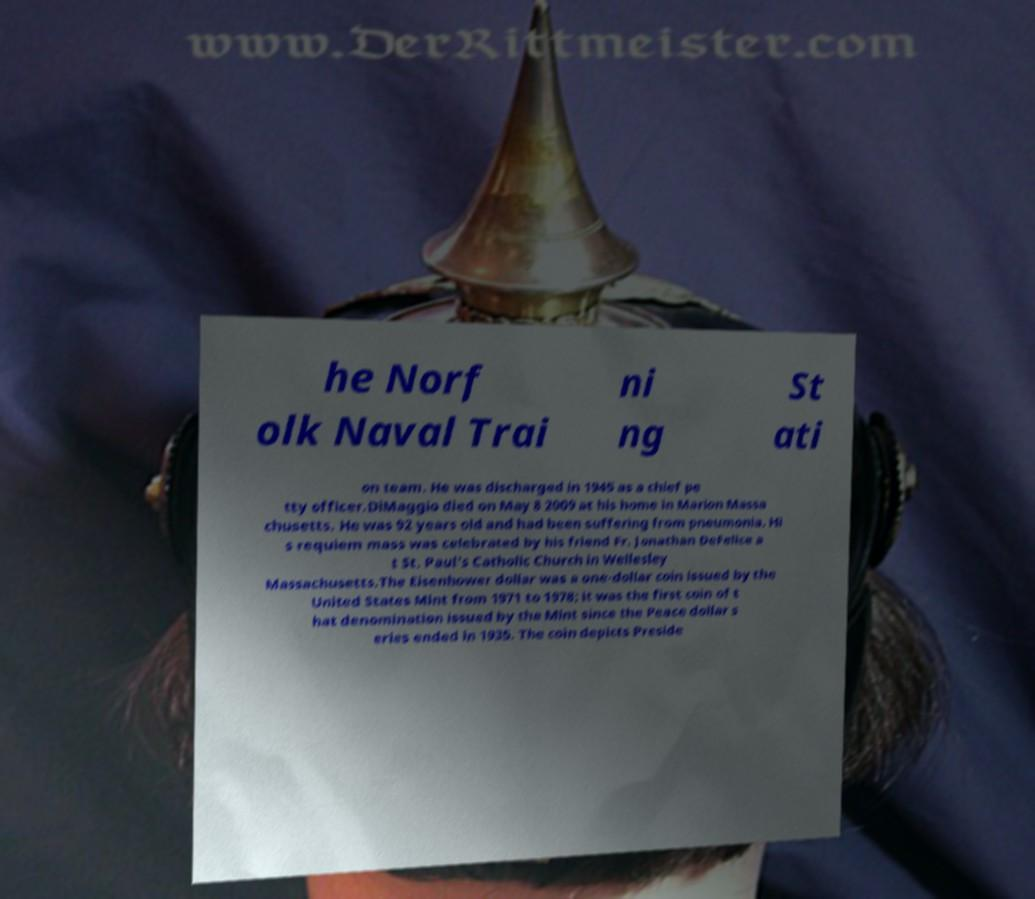There's text embedded in this image that I need extracted. Can you transcribe it verbatim? he Norf olk Naval Trai ni ng St ati on team. He was discharged in 1945 as a chief pe tty officer.DiMaggio died on May 8 2009 at his home in Marion Massa chusetts. He was 92 years old and had been suffering from pneumonia. Hi s requiem mass was celebrated by his friend Fr. Jonathan DeFelice a t St. Paul's Catholic Church in Wellesley Massachusetts.The Eisenhower dollar was a one-dollar coin issued by the United States Mint from 1971 to 1978; it was the first coin of t hat denomination issued by the Mint since the Peace dollar s eries ended in 1935. The coin depicts Preside 